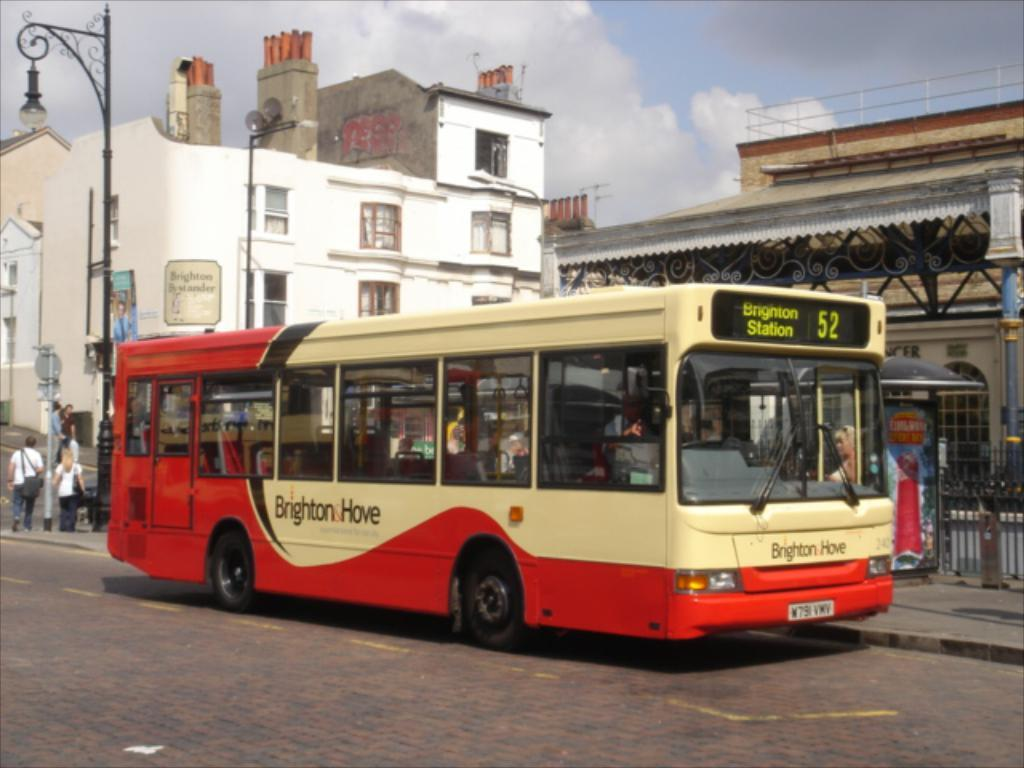<image>
Summarize the visual content of the image. A red and tan bus is heading to Brighton Station. 